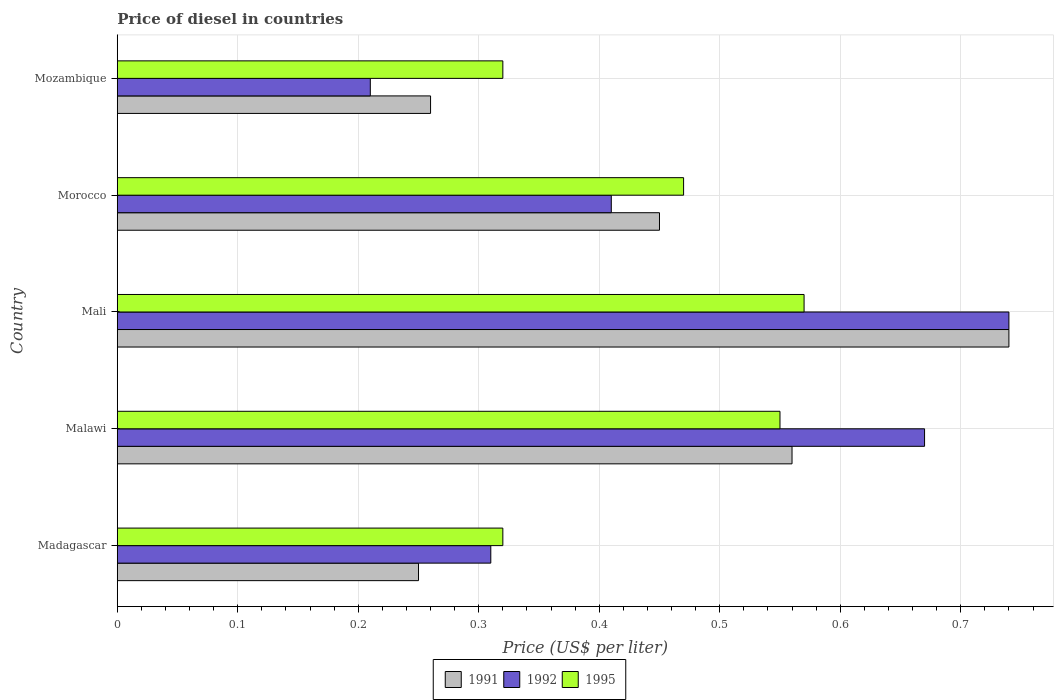Are the number of bars per tick equal to the number of legend labels?
Offer a terse response. Yes. What is the label of the 1st group of bars from the top?
Provide a succinct answer. Mozambique. What is the price of diesel in 1992 in Morocco?
Give a very brief answer. 0.41. Across all countries, what is the maximum price of diesel in 1995?
Ensure brevity in your answer.  0.57. In which country was the price of diesel in 1995 maximum?
Your answer should be very brief. Mali. In which country was the price of diesel in 1992 minimum?
Your response must be concise. Mozambique. What is the total price of diesel in 1995 in the graph?
Give a very brief answer. 2.23. What is the difference between the price of diesel in 1991 in Madagascar and that in Malawi?
Offer a terse response. -0.31. What is the difference between the price of diesel in 1992 in Morocco and the price of diesel in 1991 in Madagascar?
Keep it short and to the point. 0.16. What is the average price of diesel in 1995 per country?
Provide a short and direct response. 0.45. What is the difference between the price of diesel in 1992 and price of diesel in 1995 in Malawi?
Make the answer very short. 0.12. In how many countries, is the price of diesel in 1991 greater than 0.28 US$?
Make the answer very short. 3. What is the ratio of the price of diesel in 1992 in Madagascar to that in Malawi?
Offer a very short reply. 0.46. Is the price of diesel in 1992 in Malawi less than that in Mali?
Give a very brief answer. Yes. Is the difference between the price of diesel in 1992 in Morocco and Mozambique greater than the difference between the price of diesel in 1995 in Morocco and Mozambique?
Provide a succinct answer. Yes. What is the difference between the highest and the second highest price of diesel in 1991?
Keep it short and to the point. 0.18. What is the difference between the highest and the lowest price of diesel in 1992?
Keep it short and to the point. 0.53. In how many countries, is the price of diesel in 1992 greater than the average price of diesel in 1992 taken over all countries?
Your answer should be very brief. 2. What does the 3rd bar from the top in Malawi represents?
Your answer should be very brief. 1991. What does the 3rd bar from the bottom in Mozambique represents?
Give a very brief answer. 1995. Is it the case that in every country, the sum of the price of diesel in 1995 and price of diesel in 1991 is greater than the price of diesel in 1992?
Offer a terse response. Yes. How many bars are there?
Give a very brief answer. 15. How many countries are there in the graph?
Offer a terse response. 5. Are the values on the major ticks of X-axis written in scientific E-notation?
Your response must be concise. No. Where does the legend appear in the graph?
Give a very brief answer. Bottom center. How many legend labels are there?
Offer a terse response. 3. How are the legend labels stacked?
Offer a very short reply. Horizontal. What is the title of the graph?
Offer a terse response. Price of diesel in countries. What is the label or title of the X-axis?
Give a very brief answer. Price (US$ per liter). What is the label or title of the Y-axis?
Offer a very short reply. Country. What is the Price (US$ per liter) in 1992 in Madagascar?
Offer a very short reply. 0.31. What is the Price (US$ per liter) of 1995 in Madagascar?
Your response must be concise. 0.32. What is the Price (US$ per liter) of 1991 in Malawi?
Offer a very short reply. 0.56. What is the Price (US$ per liter) of 1992 in Malawi?
Keep it short and to the point. 0.67. What is the Price (US$ per liter) of 1995 in Malawi?
Your answer should be compact. 0.55. What is the Price (US$ per liter) of 1991 in Mali?
Keep it short and to the point. 0.74. What is the Price (US$ per liter) of 1992 in Mali?
Give a very brief answer. 0.74. What is the Price (US$ per liter) of 1995 in Mali?
Your answer should be very brief. 0.57. What is the Price (US$ per liter) of 1991 in Morocco?
Give a very brief answer. 0.45. What is the Price (US$ per liter) in 1992 in Morocco?
Your answer should be compact. 0.41. What is the Price (US$ per liter) of 1995 in Morocco?
Offer a terse response. 0.47. What is the Price (US$ per liter) of 1991 in Mozambique?
Offer a very short reply. 0.26. What is the Price (US$ per liter) in 1992 in Mozambique?
Provide a succinct answer. 0.21. What is the Price (US$ per liter) of 1995 in Mozambique?
Provide a succinct answer. 0.32. Across all countries, what is the maximum Price (US$ per liter) of 1991?
Offer a very short reply. 0.74. Across all countries, what is the maximum Price (US$ per liter) of 1992?
Ensure brevity in your answer.  0.74. Across all countries, what is the maximum Price (US$ per liter) of 1995?
Offer a terse response. 0.57. Across all countries, what is the minimum Price (US$ per liter) of 1992?
Your answer should be compact. 0.21. Across all countries, what is the minimum Price (US$ per liter) in 1995?
Offer a terse response. 0.32. What is the total Price (US$ per liter) of 1991 in the graph?
Your response must be concise. 2.26. What is the total Price (US$ per liter) in 1992 in the graph?
Keep it short and to the point. 2.34. What is the total Price (US$ per liter) of 1995 in the graph?
Ensure brevity in your answer.  2.23. What is the difference between the Price (US$ per liter) in 1991 in Madagascar and that in Malawi?
Provide a succinct answer. -0.31. What is the difference between the Price (US$ per liter) of 1992 in Madagascar and that in Malawi?
Your answer should be compact. -0.36. What is the difference between the Price (US$ per liter) in 1995 in Madagascar and that in Malawi?
Keep it short and to the point. -0.23. What is the difference between the Price (US$ per liter) in 1991 in Madagascar and that in Mali?
Provide a succinct answer. -0.49. What is the difference between the Price (US$ per liter) in 1992 in Madagascar and that in Mali?
Offer a terse response. -0.43. What is the difference between the Price (US$ per liter) of 1995 in Madagascar and that in Mali?
Your answer should be compact. -0.25. What is the difference between the Price (US$ per liter) in 1991 in Madagascar and that in Morocco?
Offer a very short reply. -0.2. What is the difference between the Price (US$ per liter) of 1992 in Madagascar and that in Morocco?
Offer a terse response. -0.1. What is the difference between the Price (US$ per liter) in 1995 in Madagascar and that in Morocco?
Your answer should be compact. -0.15. What is the difference between the Price (US$ per liter) in 1991 in Madagascar and that in Mozambique?
Offer a terse response. -0.01. What is the difference between the Price (US$ per liter) of 1992 in Madagascar and that in Mozambique?
Your answer should be compact. 0.1. What is the difference between the Price (US$ per liter) in 1991 in Malawi and that in Mali?
Ensure brevity in your answer.  -0.18. What is the difference between the Price (US$ per liter) of 1992 in Malawi and that in Mali?
Offer a terse response. -0.07. What is the difference between the Price (US$ per liter) of 1995 in Malawi and that in Mali?
Ensure brevity in your answer.  -0.02. What is the difference between the Price (US$ per liter) of 1991 in Malawi and that in Morocco?
Provide a short and direct response. 0.11. What is the difference between the Price (US$ per liter) of 1992 in Malawi and that in Morocco?
Make the answer very short. 0.26. What is the difference between the Price (US$ per liter) of 1991 in Malawi and that in Mozambique?
Your answer should be compact. 0.3. What is the difference between the Price (US$ per liter) in 1992 in Malawi and that in Mozambique?
Offer a very short reply. 0.46. What is the difference between the Price (US$ per liter) in 1995 in Malawi and that in Mozambique?
Your answer should be compact. 0.23. What is the difference between the Price (US$ per liter) of 1991 in Mali and that in Morocco?
Give a very brief answer. 0.29. What is the difference between the Price (US$ per liter) of 1992 in Mali and that in Morocco?
Provide a short and direct response. 0.33. What is the difference between the Price (US$ per liter) of 1995 in Mali and that in Morocco?
Ensure brevity in your answer.  0.1. What is the difference between the Price (US$ per liter) in 1991 in Mali and that in Mozambique?
Offer a very short reply. 0.48. What is the difference between the Price (US$ per liter) of 1992 in Mali and that in Mozambique?
Your answer should be very brief. 0.53. What is the difference between the Price (US$ per liter) in 1995 in Mali and that in Mozambique?
Give a very brief answer. 0.25. What is the difference between the Price (US$ per liter) of 1991 in Morocco and that in Mozambique?
Provide a short and direct response. 0.19. What is the difference between the Price (US$ per liter) in 1995 in Morocco and that in Mozambique?
Your answer should be very brief. 0.15. What is the difference between the Price (US$ per liter) of 1991 in Madagascar and the Price (US$ per liter) of 1992 in Malawi?
Your answer should be compact. -0.42. What is the difference between the Price (US$ per liter) in 1992 in Madagascar and the Price (US$ per liter) in 1995 in Malawi?
Ensure brevity in your answer.  -0.24. What is the difference between the Price (US$ per liter) in 1991 in Madagascar and the Price (US$ per liter) in 1992 in Mali?
Provide a short and direct response. -0.49. What is the difference between the Price (US$ per liter) in 1991 in Madagascar and the Price (US$ per liter) in 1995 in Mali?
Make the answer very short. -0.32. What is the difference between the Price (US$ per liter) in 1992 in Madagascar and the Price (US$ per liter) in 1995 in Mali?
Offer a very short reply. -0.26. What is the difference between the Price (US$ per liter) of 1991 in Madagascar and the Price (US$ per liter) of 1992 in Morocco?
Your answer should be compact. -0.16. What is the difference between the Price (US$ per liter) of 1991 in Madagascar and the Price (US$ per liter) of 1995 in Morocco?
Offer a very short reply. -0.22. What is the difference between the Price (US$ per liter) in 1992 in Madagascar and the Price (US$ per liter) in 1995 in Morocco?
Give a very brief answer. -0.16. What is the difference between the Price (US$ per liter) in 1991 in Madagascar and the Price (US$ per liter) in 1995 in Mozambique?
Ensure brevity in your answer.  -0.07. What is the difference between the Price (US$ per liter) in 1992 in Madagascar and the Price (US$ per liter) in 1995 in Mozambique?
Ensure brevity in your answer.  -0.01. What is the difference between the Price (US$ per liter) of 1991 in Malawi and the Price (US$ per liter) of 1992 in Mali?
Your response must be concise. -0.18. What is the difference between the Price (US$ per liter) in 1991 in Malawi and the Price (US$ per liter) in 1995 in Mali?
Offer a terse response. -0.01. What is the difference between the Price (US$ per liter) in 1991 in Malawi and the Price (US$ per liter) in 1995 in Morocco?
Provide a succinct answer. 0.09. What is the difference between the Price (US$ per liter) of 1992 in Malawi and the Price (US$ per liter) of 1995 in Morocco?
Give a very brief answer. 0.2. What is the difference between the Price (US$ per liter) in 1991 in Malawi and the Price (US$ per liter) in 1992 in Mozambique?
Your answer should be very brief. 0.35. What is the difference between the Price (US$ per liter) of 1991 in Malawi and the Price (US$ per liter) of 1995 in Mozambique?
Give a very brief answer. 0.24. What is the difference between the Price (US$ per liter) of 1992 in Malawi and the Price (US$ per liter) of 1995 in Mozambique?
Give a very brief answer. 0.35. What is the difference between the Price (US$ per liter) in 1991 in Mali and the Price (US$ per liter) in 1992 in Morocco?
Provide a short and direct response. 0.33. What is the difference between the Price (US$ per liter) of 1991 in Mali and the Price (US$ per liter) of 1995 in Morocco?
Offer a terse response. 0.27. What is the difference between the Price (US$ per liter) of 1992 in Mali and the Price (US$ per liter) of 1995 in Morocco?
Your response must be concise. 0.27. What is the difference between the Price (US$ per liter) of 1991 in Mali and the Price (US$ per liter) of 1992 in Mozambique?
Offer a very short reply. 0.53. What is the difference between the Price (US$ per liter) in 1991 in Mali and the Price (US$ per liter) in 1995 in Mozambique?
Your answer should be compact. 0.42. What is the difference between the Price (US$ per liter) in 1992 in Mali and the Price (US$ per liter) in 1995 in Mozambique?
Give a very brief answer. 0.42. What is the difference between the Price (US$ per liter) in 1991 in Morocco and the Price (US$ per liter) in 1992 in Mozambique?
Provide a succinct answer. 0.24. What is the difference between the Price (US$ per liter) in 1991 in Morocco and the Price (US$ per liter) in 1995 in Mozambique?
Ensure brevity in your answer.  0.13. What is the difference between the Price (US$ per liter) of 1992 in Morocco and the Price (US$ per liter) of 1995 in Mozambique?
Provide a short and direct response. 0.09. What is the average Price (US$ per liter) in 1991 per country?
Provide a succinct answer. 0.45. What is the average Price (US$ per liter) in 1992 per country?
Keep it short and to the point. 0.47. What is the average Price (US$ per liter) in 1995 per country?
Offer a terse response. 0.45. What is the difference between the Price (US$ per liter) of 1991 and Price (US$ per liter) of 1992 in Madagascar?
Provide a short and direct response. -0.06. What is the difference between the Price (US$ per liter) of 1991 and Price (US$ per liter) of 1995 in Madagascar?
Your answer should be very brief. -0.07. What is the difference between the Price (US$ per liter) in 1992 and Price (US$ per liter) in 1995 in Madagascar?
Provide a short and direct response. -0.01. What is the difference between the Price (US$ per liter) in 1991 and Price (US$ per liter) in 1992 in Malawi?
Keep it short and to the point. -0.11. What is the difference between the Price (US$ per liter) in 1991 and Price (US$ per liter) in 1995 in Malawi?
Offer a very short reply. 0.01. What is the difference between the Price (US$ per liter) of 1992 and Price (US$ per liter) of 1995 in Malawi?
Your answer should be very brief. 0.12. What is the difference between the Price (US$ per liter) of 1991 and Price (US$ per liter) of 1995 in Mali?
Offer a very short reply. 0.17. What is the difference between the Price (US$ per liter) of 1992 and Price (US$ per liter) of 1995 in Mali?
Provide a succinct answer. 0.17. What is the difference between the Price (US$ per liter) in 1991 and Price (US$ per liter) in 1992 in Morocco?
Give a very brief answer. 0.04. What is the difference between the Price (US$ per liter) in 1991 and Price (US$ per liter) in 1995 in Morocco?
Provide a short and direct response. -0.02. What is the difference between the Price (US$ per liter) in 1992 and Price (US$ per liter) in 1995 in Morocco?
Make the answer very short. -0.06. What is the difference between the Price (US$ per liter) of 1991 and Price (US$ per liter) of 1995 in Mozambique?
Your answer should be compact. -0.06. What is the difference between the Price (US$ per liter) in 1992 and Price (US$ per liter) in 1995 in Mozambique?
Ensure brevity in your answer.  -0.11. What is the ratio of the Price (US$ per liter) in 1991 in Madagascar to that in Malawi?
Make the answer very short. 0.45. What is the ratio of the Price (US$ per liter) in 1992 in Madagascar to that in Malawi?
Give a very brief answer. 0.46. What is the ratio of the Price (US$ per liter) in 1995 in Madagascar to that in Malawi?
Provide a short and direct response. 0.58. What is the ratio of the Price (US$ per liter) of 1991 in Madagascar to that in Mali?
Provide a succinct answer. 0.34. What is the ratio of the Price (US$ per liter) in 1992 in Madagascar to that in Mali?
Your response must be concise. 0.42. What is the ratio of the Price (US$ per liter) of 1995 in Madagascar to that in Mali?
Ensure brevity in your answer.  0.56. What is the ratio of the Price (US$ per liter) in 1991 in Madagascar to that in Morocco?
Ensure brevity in your answer.  0.56. What is the ratio of the Price (US$ per liter) of 1992 in Madagascar to that in Morocco?
Your response must be concise. 0.76. What is the ratio of the Price (US$ per liter) of 1995 in Madagascar to that in Morocco?
Your answer should be very brief. 0.68. What is the ratio of the Price (US$ per liter) of 1991 in Madagascar to that in Mozambique?
Your answer should be compact. 0.96. What is the ratio of the Price (US$ per liter) in 1992 in Madagascar to that in Mozambique?
Your response must be concise. 1.48. What is the ratio of the Price (US$ per liter) of 1991 in Malawi to that in Mali?
Offer a very short reply. 0.76. What is the ratio of the Price (US$ per liter) of 1992 in Malawi to that in Mali?
Make the answer very short. 0.91. What is the ratio of the Price (US$ per liter) in 1995 in Malawi to that in Mali?
Give a very brief answer. 0.96. What is the ratio of the Price (US$ per liter) in 1991 in Malawi to that in Morocco?
Offer a terse response. 1.24. What is the ratio of the Price (US$ per liter) in 1992 in Malawi to that in Morocco?
Your response must be concise. 1.63. What is the ratio of the Price (US$ per liter) of 1995 in Malawi to that in Morocco?
Your answer should be very brief. 1.17. What is the ratio of the Price (US$ per liter) in 1991 in Malawi to that in Mozambique?
Ensure brevity in your answer.  2.15. What is the ratio of the Price (US$ per liter) of 1992 in Malawi to that in Mozambique?
Your answer should be compact. 3.19. What is the ratio of the Price (US$ per liter) in 1995 in Malawi to that in Mozambique?
Give a very brief answer. 1.72. What is the ratio of the Price (US$ per liter) of 1991 in Mali to that in Morocco?
Your answer should be very brief. 1.64. What is the ratio of the Price (US$ per liter) in 1992 in Mali to that in Morocco?
Provide a succinct answer. 1.8. What is the ratio of the Price (US$ per liter) in 1995 in Mali to that in Morocco?
Provide a succinct answer. 1.21. What is the ratio of the Price (US$ per liter) of 1991 in Mali to that in Mozambique?
Provide a short and direct response. 2.85. What is the ratio of the Price (US$ per liter) of 1992 in Mali to that in Mozambique?
Give a very brief answer. 3.52. What is the ratio of the Price (US$ per liter) of 1995 in Mali to that in Mozambique?
Offer a terse response. 1.78. What is the ratio of the Price (US$ per liter) in 1991 in Morocco to that in Mozambique?
Ensure brevity in your answer.  1.73. What is the ratio of the Price (US$ per liter) of 1992 in Morocco to that in Mozambique?
Offer a terse response. 1.95. What is the ratio of the Price (US$ per liter) of 1995 in Morocco to that in Mozambique?
Keep it short and to the point. 1.47. What is the difference between the highest and the second highest Price (US$ per liter) of 1991?
Give a very brief answer. 0.18. What is the difference between the highest and the second highest Price (US$ per liter) of 1992?
Your answer should be very brief. 0.07. What is the difference between the highest and the second highest Price (US$ per liter) of 1995?
Give a very brief answer. 0.02. What is the difference between the highest and the lowest Price (US$ per liter) of 1991?
Ensure brevity in your answer.  0.49. What is the difference between the highest and the lowest Price (US$ per liter) in 1992?
Provide a short and direct response. 0.53. 